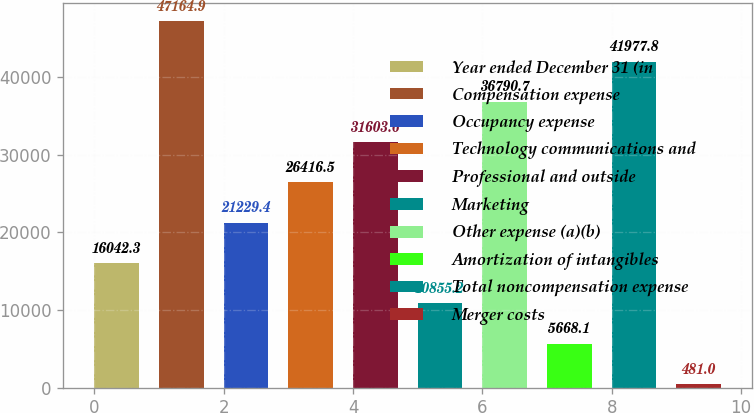Convert chart to OTSL. <chart><loc_0><loc_0><loc_500><loc_500><bar_chart><fcel>Year ended December 31 (in<fcel>Compensation expense<fcel>Occupancy expense<fcel>Technology communications and<fcel>Professional and outside<fcel>Marketing<fcel>Other expense (a)(b)<fcel>Amortization of intangibles<fcel>Total noncompensation expense<fcel>Merger costs<nl><fcel>16042.3<fcel>47164.9<fcel>21229.4<fcel>26416.5<fcel>31603.6<fcel>10855.2<fcel>36790.7<fcel>5668.1<fcel>41977.8<fcel>481<nl></chart> 